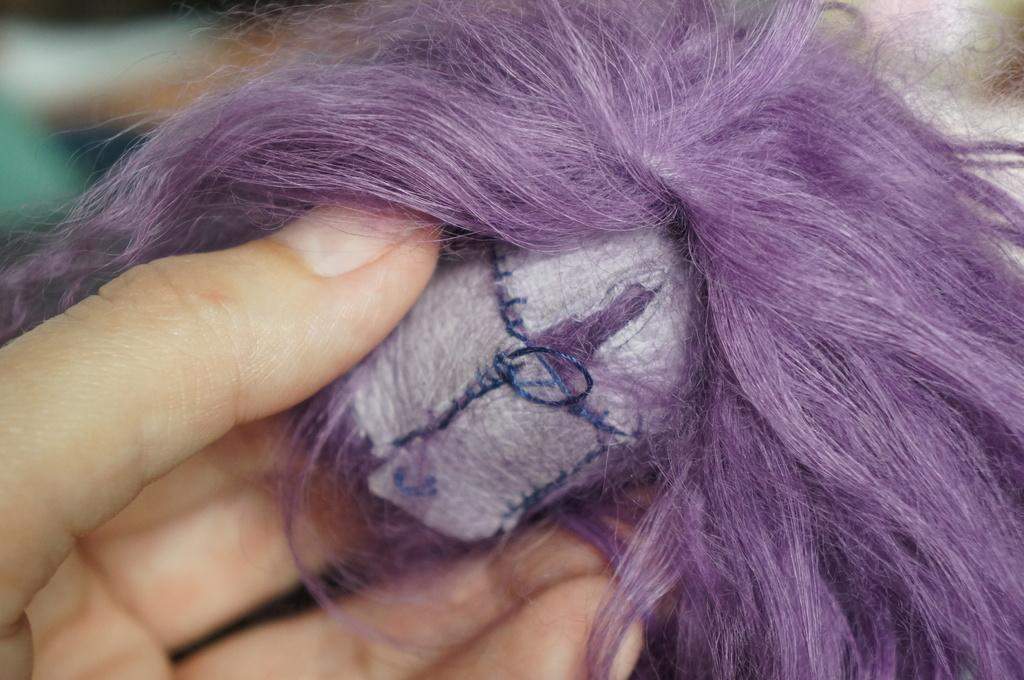What is the main focus of the image? The main focus of the image is a person's hand. What is the person's hand doing in the image? The person is holding an object. Can you describe the background of the image? The background of the image is blurred. What type of cave can be seen in the background of the image? There is no cave present in the image; the background is blurred. How many lines are visible in the image? There is no specific mention of lines in the image, so it is not possible to determine the number of lines. 